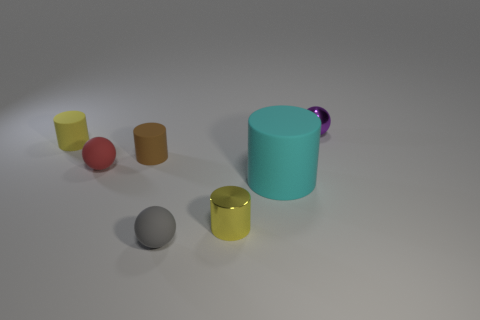Does the tiny cylinder that is on the left side of the tiny brown matte object have the same color as the small shiny cylinder?
Your answer should be compact. Yes. There is another cylinder that is the same color as the metallic cylinder; what is its size?
Provide a short and direct response. Small. Are there any things of the same color as the tiny metal cylinder?
Your response must be concise. Yes. What number of things are either gray balls or large blue metal things?
Your answer should be compact. 1. Is the shape of the rubber object that is in front of the big cyan rubber cylinder the same as the yellow object in front of the small red rubber object?
Offer a terse response. No. There is a metal thing behind the brown cylinder; what shape is it?
Make the answer very short. Sphere. Are there an equal number of shiny balls that are on the left side of the purple metallic thing and rubber things behind the cyan rubber thing?
Offer a terse response. No. How many things are big metallic spheres or small balls that are behind the tiny gray rubber ball?
Your response must be concise. 2. What is the shape of the tiny object that is both in front of the purple ball and right of the gray ball?
Offer a very short reply. Cylinder. What material is the thing in front of the metal object in front of the brown thing?
Keep it short and to the point. Rubber. 